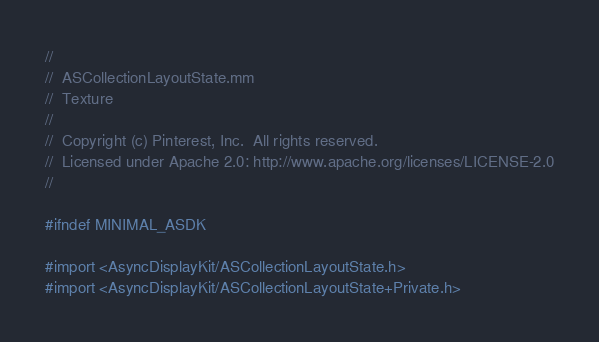<code> <loc_0><loc_0><loc_500><loc_500><_ObjectiveC_>//
//  ASCollectionLayoutState.mm
//  Texture
//
//  Copyright (c) Pinterest, Inc.  All rights reserved.
//  Licensed under Apache 2.0: http://www.apache.org/licenses/LICENSE-2.0
//

#ifndef MINIMAL_ASDK

#import <AsyncDisplayKit/ASCollectionLayoutState.h>
#import <AsyncDisplayKit/ASCollectionLayoutState+Private.h>
</code> 